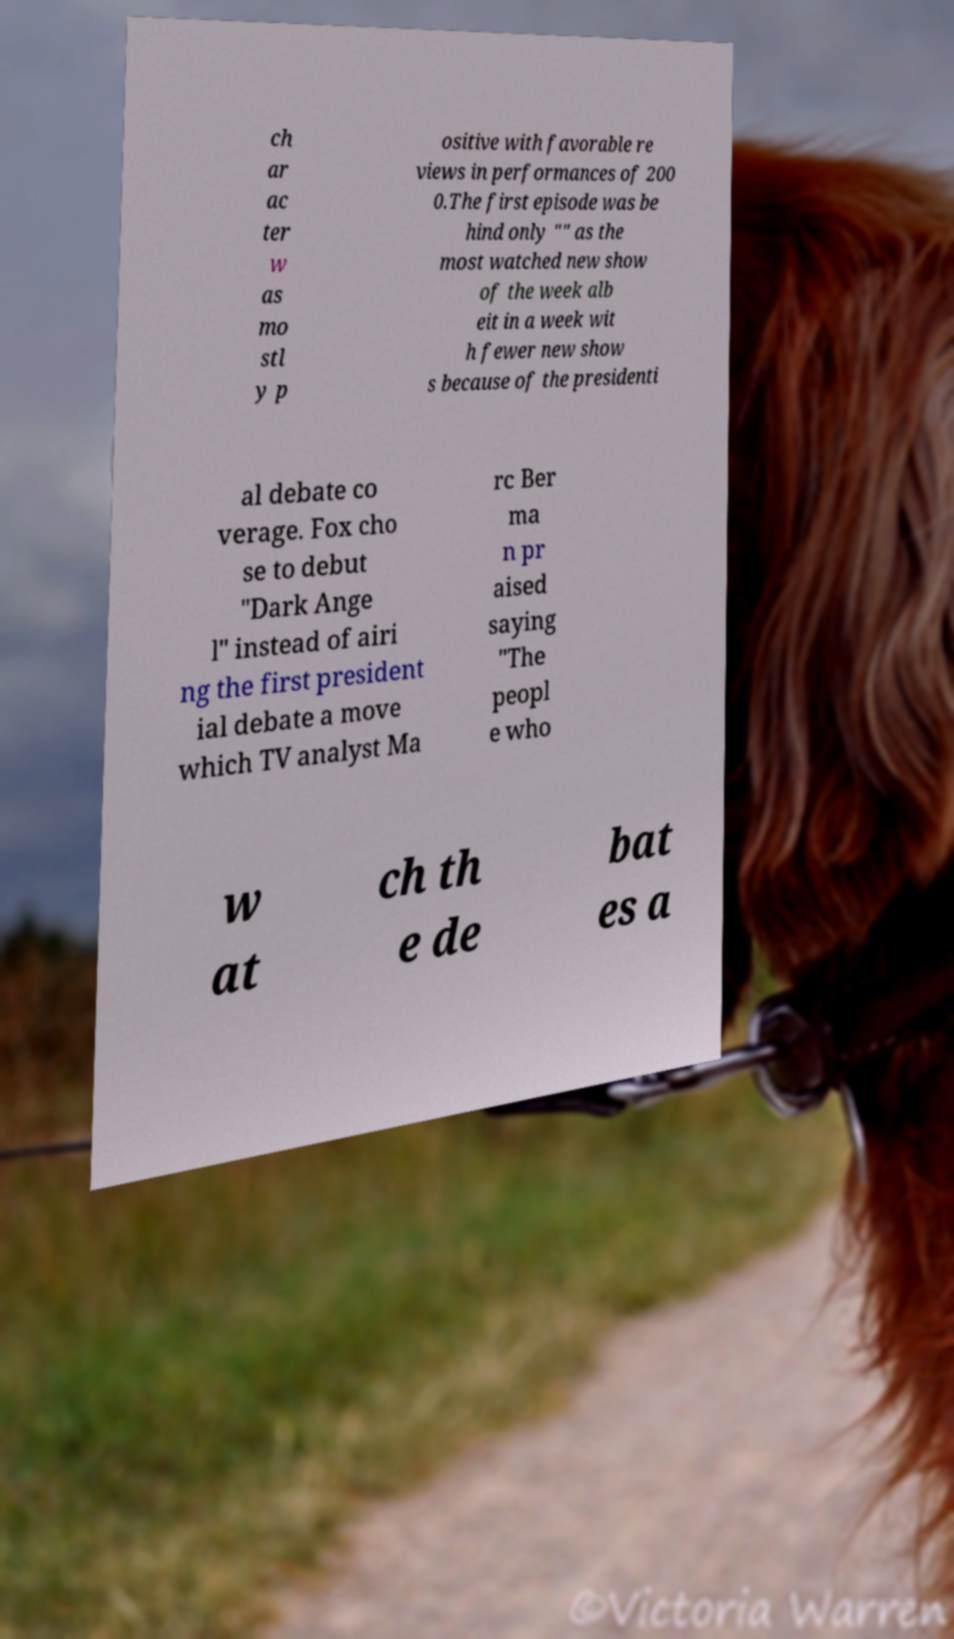Could you extract and type out the text from this image? ch ar ac ter w as mo stl y p ositive with favorable re views in performances of 200 0.The first episode was be hind only "" as the most watched new show of the week alb eit in a week wit h fewer new show s because of the presidenti al debate co verage. Fox cho se to debut "Dark Ange l" instead of airi ng the first president ial debate a move which TV analyst Ma rc Ber ma n pr aised saying "The peopl e who w at ch th e de bat es a 